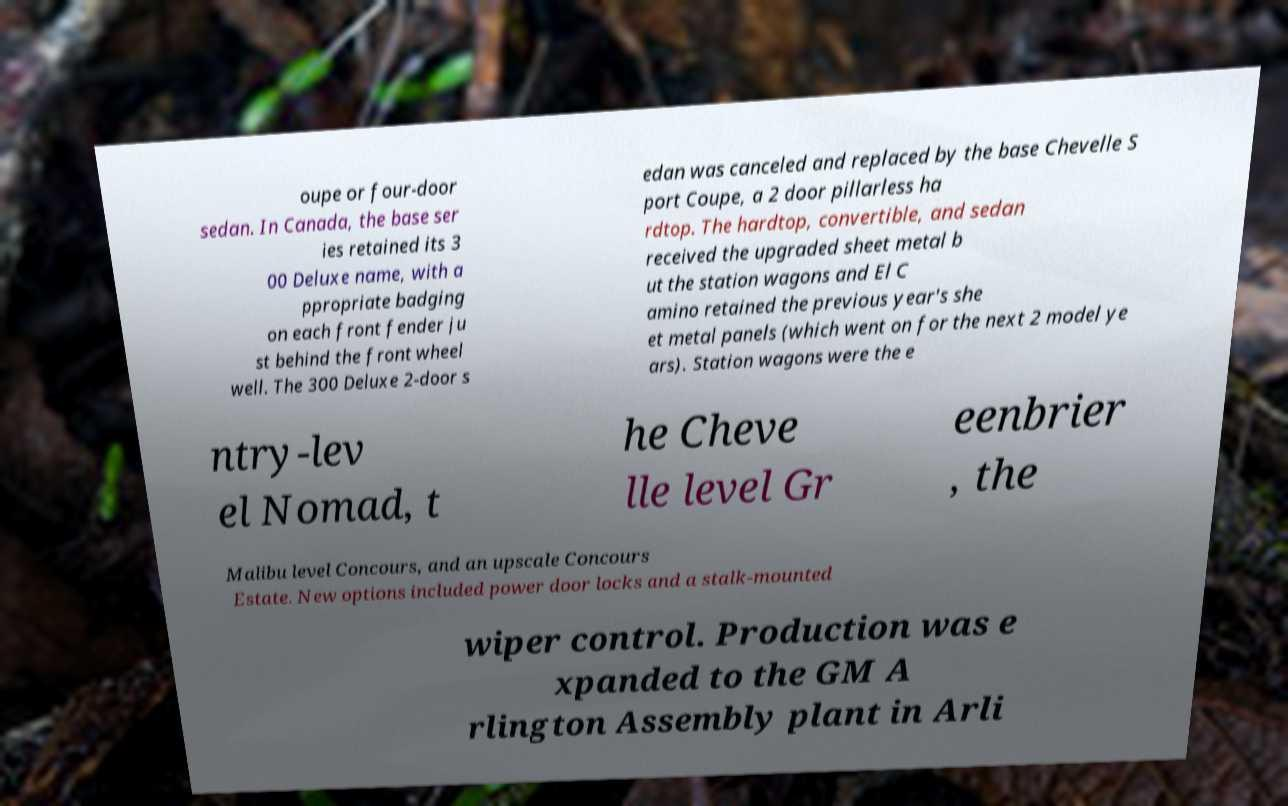Please read and relay the text visible in this image. What does it say? oupe or four-door sedan. In Canada, the base ser ies retained its 3 00 Deluxe name, with a ppropriate badging on each front fender ju st behind the front wheel well. The 300 Deluxe 2-door s edan was canceled and replaced by the base Chevelle S port Coupe, a 2 door pillarless ha rdtop. The hardtop, convertible, and sedan received the upgraded sheet metal b ut the station wagons and El C amino retained the previous year's she et metal panels (which went on for the next 2 model ye ars). Station wagons were the e ntry-lev el Nomad, t he Cheve lle level Gr eenbrier , the Malibu level Concours, and an upscale Concours Estate. New options included power door locks and a stalk-mounted wiper control. Production was e xpanded to the GM A rlington Assembly plant in Arli 